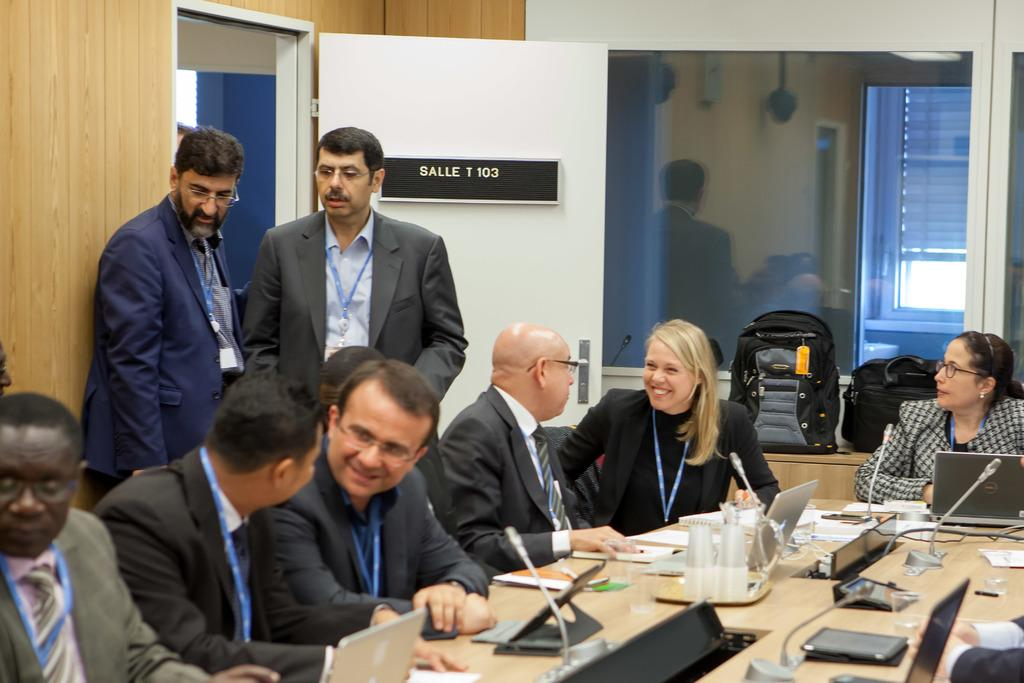What are the people in the image doing? The people in the image are seated and speaking to each other. What type of furniture is present in the image? There are chairs in the image. What electronic devices can be seen on the table? There are laptops ons on the table. What else is present on the table besides laptops? There are papers and microphones on the table. Are there any people standing in the image? Yes, there are men standing in the image. What type of knee injury is the grandfather suffering from in the image? There is no grandfather or knee injury present in the image. What type of party is being held in the image? There is no party depicted in the image. 